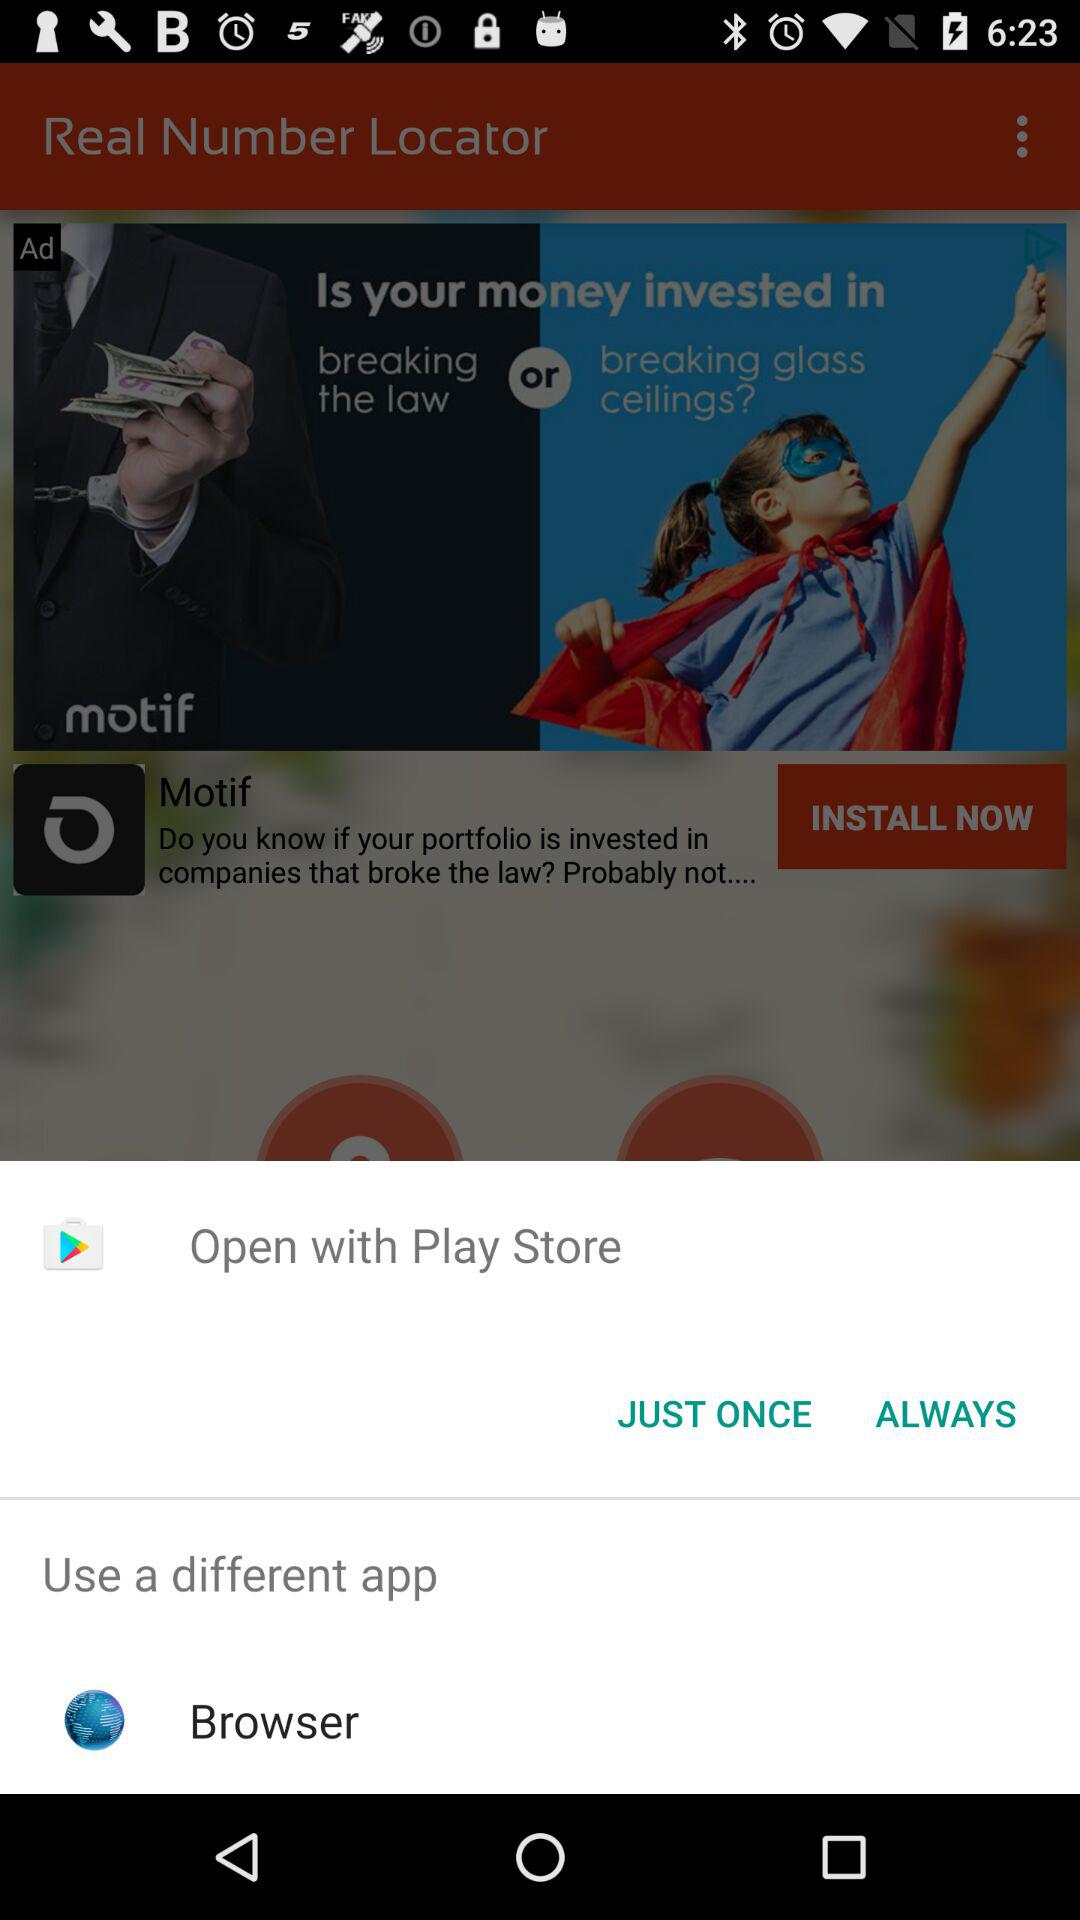What is the name of the application? The name of the application is "Real Number Locator". 